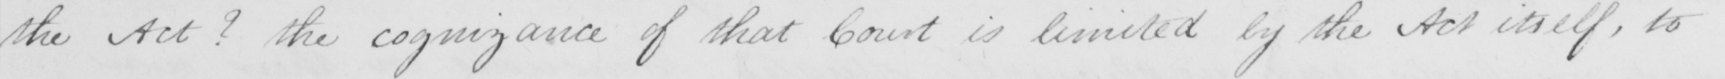Transcribe the text shown in this historical manuscript line. the Act ?  the cognizance of that Court is limited by the Act itself , to 